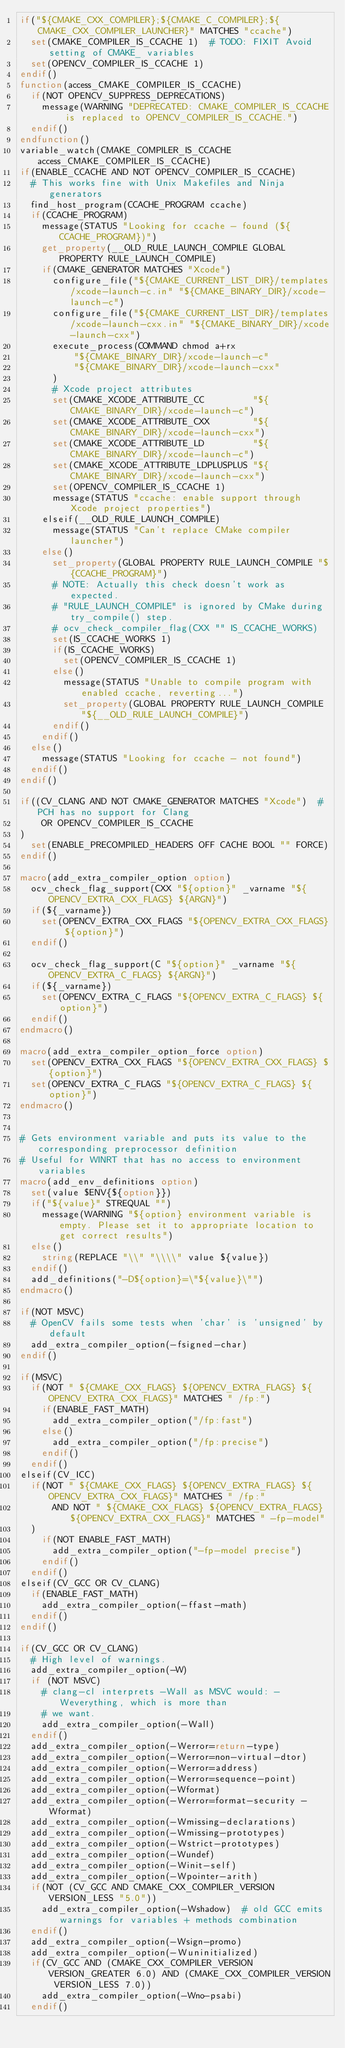<code> <loc_0><loc_0><loc_500><loc_500><_CMake_>if("${CMAKE_CXX_COMPILER};${CMAKE_C_COMPILER};${CMAKE_CXX_COMPILER_LAUNCHER}" MATCHES "ccache")
  set(CMAKE_COMPILER_IS_CCACHE 1)  # TODO: FIXIT Avoid setting of CMAKE_ variables
  set(OPENCV_COMPILER_IS_CCACHE 1)
endif()
function(access_CMAKE_COMPILER_IS_CCACHE)
  if(NOT OPENCV_SUPPRESS_DEPRECATIONS)
    message(WARNING "DEPRECATED: CMAKE_COMPILER_IS_CCACHE is replaced to OPENCV_COMPILER_IS_CCACHE.")
  endif()
endfunction()
variable_watch(CMAKE_COMPILER_IS_CCACHE access_CMAKE_COMPILER_IS_CCACHE)
if(ENABLE_CCACHE AND NOT OPENCV_COMPILER_IS_CCACHE)
  # This works fine with Unix Makefiles and Ninja generators
  find_host_program(CCACHE_PROGRAM ccache)
  if(CCACHE_PROGRAM)
    message(STATUS "Looking for ccache - found (${CCACHE_PROGRAM})")
    get_property(__OLD_RULE_LAUNCH_COMPILE GLOBAL PROPERTY RULE_LAUNCH_COMPILE)
    if(CMAKE_GENERATOR MATCHES "Xcode")
      configure_file("${CMAKE_CURRENT_LIST_DIR}/templates/xcode-launch-c.in" "${CMAKE_BINARY_DIR}/xcode-launch-c")
      configure_file("${CMAKE_CURRENT_LIST_DIR}/templates/xcode-launch-cxx.in" "${CMAKE_BINARY_DIR}/xcode-launch-cxx")
      execute_process(COMMAND chmod a+rx
          "${CMAKE_BINARY_DIR}/xcode-launch-c"
          "${CMAKE_BINARY_DIR}/xcode-launch-cxx"
      )
      # Xcode project attributes
      set(CMAKE_XCODE_ATTRIBUTE_CC         "${CMAKE_BINARY_DIR}/xcode-launch-c")
      set(CMAKE_XCODE_ATTRIBUTE_CXX        "${CMAKE_BINARY_DIR}/xcode-launch-cxx")
      set(CMAKE_XCODE_ATTRIBUTE_LD         "${CMAKE_BINARY_DIR}/xcode-launch-c")
      set(CMAKE_XCODE_ATTRIBUTE_LDPLUSPLUS "${CMAKE_BINARY_DIR}/xcode-launch-cxx")
      set(OPENCV_COMPILER_IS_CCACHE 1)
      message(STATUS "ccache: enable support through Xcode project properties")
    elseif(__OLD_RULE_LAUNCH_COMPILE)
      message(STATUS "Can't replace CMake compiler launcher")
    else()
      set_property(GLOBAL PROPERTY RULE_LAUNCH_COMPILE "${CCACHE_PROGRAM}")
      # NOTE: Actually this check doesn't work as expected.
      # "RULE_LAUNCH_COMPILE" is ignored by CMake during try_compile() step.
      # ocv_check_compiler_flag(CXX "" IS_CCACHE_WORKS)
      set(IS_CCACHE_WORKS 1)
      if(IS_CCACHE_WORKS)
        set(OPENCV_COMPILER_IS_CCACHE 1)
      else()
        message(STATUS "Unable to compile program with enabled ccache, reverting...")
        set_property(GLOBAL PROPERTY RULE_LAUNCH_COMPILE "${__OLD_RULE_LAUNCH_COMPILE}")
      endif()
    endif()
  else()
    message(STATUS "Looking for ccache - not found")
  endif()
endif()

if((CV_CLANG AND NOT CMAKE_GENERATOR MATCHES "Xcode")  # PCH has no support for Clang
    OR OPENCV_COMPILER_IS_CCACHE
)
  set(ENABLE_PRECOMPILED_HEADERS OFF CACHE BOOL "" FORCE)
endif()

macro(add_extra_compiler_option option)
  ocv_check_flag_support(CXX "${option}" _varname "${OPENCV_EXTRA_CXX_FLAGS} ${ARGN}")
  if(${_varname})
    set(OPENCV_EXTRA_CXX_FLAGS "${OPENCV_EXTRA_CXX_FLAGS} ${option}")
  endif()

  ocv_check_flag_support(C "${option}" _varname "${OPENCV_EXTRA_C_FLAGS} ${ARGN}")
  if(${_varname})
    set(OPENCV_EXTRA_C_FLAGS "${OPENCV_EXTRA_C_FLAGS} ${option}")
  endif()
endmacro()

macro(add_extra_compiler_option_force option)
  set(OPENCV_EXTRA_CXX_FLAGS "${OPENCV_EXTRA_CXX_FLAGS} ${option}")
  set(OPENCV_EXTRA_C_FLAGS "${OPENCV_EXTRA_C_FLAGS} ${option}")
endmacro()


# Gets environment variable and puts its value to the corresponding preprocessor definition
# Useful for WINRT that has no access to environment variables
macro(add_env_definitions option)
  set(value $ENV{${option}})
  if("${value}" STREQUAL "")
    message(WARNING "${option} environment variable is empty. Please set it to appropriate location to get correct results")
  else()
    string(REPLACE "\\" "\\\\" value ${value})
  endif()
  add_definitions("-D${option}=\"${value}\"")
endmacro()

if(NOT MSVC)
  # OpenCV fails some tests when 'char' is 'unsigned' by default
  add_extra_compiler_option(-fsigned-char)
endif()

if(MSVC)
  if(NOT " ${CMAKE_CXX_FLAGS} ${OPENCV_EXTRA_FLAGS} ${OPENCV_EXTRA_CXX_FLAGS}" MATCHES " /fp:")
    if(ENABLE_FAST_MATH)
      add_extra_compiler_option("/fp:fast")
    else()
      add_extra_compiler_option("/fp:precise")
    endif()
  endif()
elseif(CV_ICC)
  if(NOT " ${CMAKE_CXX_FLAGS} ${OPENCV_EXTRA_FLAGS} ${OPENCV_EXTRA_CXX_FLAGS}" MATCHES " /fp:"
      AND NOT " ${CMAKE_CXX_FLAGS} ${OPENCV_EXTRA_FLAGS} ${OPENCV_EXTRA_CXX_FLAGS}" MATCHES " -fp-model"
  )
    if(NOT ENABLE_FAST_MATH)
      add_extra_compiler_option("-fp-model precise")
    endif()
  endif()
elseif(CV_GCC OR CV_CLANG)
  if(ENABLE_FAST_MATH)
    add_extra_compiler_option(-ffast-math)
  endif()
endif()

if(CV_GCC OR CV_CLANG)
  # High level of warnings.
  add_extra_compiler_option(-W)
  if (NOT MSVC)
    # clang-cl interprets -Wall as MSVC would: -Weverything, which is more than
    # we want.
    add_extra_compiler_option(-Wall)
  endif()
  add_extra_compiler_option(-Werror=return-type)
  add_extra_compiler_option(-Werror=non-virtual-dtor)
  add_extra_compiler_option(-Werror=address)
  add_extra_compiler_option(-Werror=sequence-point)
  add_extra_compiler_option(-Wformat)
  add_extra_compiler_option(-Werror=format-security -Wformat)
  add_extra_compiler_option(-Wmissing-declarations)
  add_extra_compiler_option(-Wmissing-prototypes)
  add_extra_compiler_option(-Wstrict-prototypes)
  add_extra_compiler_option(-Wundef)
  add_extra_compiler_option(-Winit-self)
  add_extra_compiler_option(-Wpointer-arith)
  if(NOT (CV_GCC AND CMAKE_CXX_COMPILER_VERSION VERSION_LESS "5.0"))
    add_extra_compiler_option(-Wshadow)  # old GCC emits warnings for variables + methods combination
  endif()
  add_extra_compiler_option(-Wsign-promo)
  add_extra_compiler_option(-Wuninitialized)
  if(CV_GCC AND (CMAKE_CXX_COMPILER_VERSION VERSION_GREATER 6.0) AND (CMAKE_CXX_COMPILER_VERSION VERSION_LESS 7.0))
    add_extra_compiler_option(-Wno-psabi)
  endif()</code> 